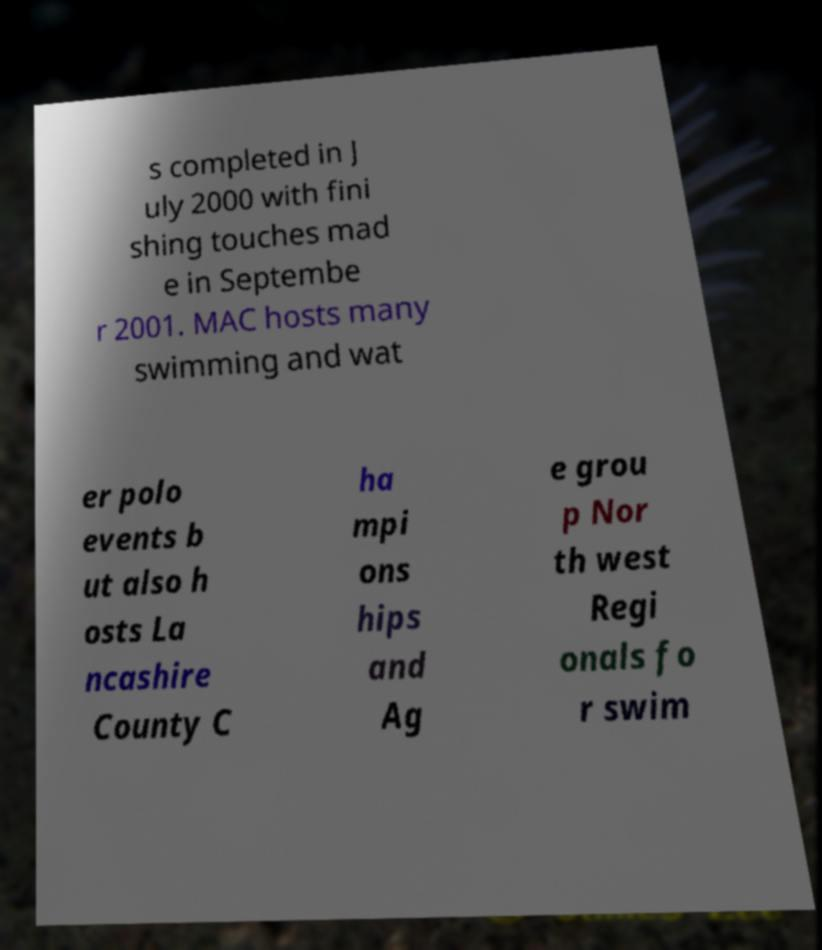Could you extract and type out the text from this image? s completed in J uly 2000 with fini shing touches mad e in Septembe r 2001. MAC hosts many swimming and wat er polo events b ut also h osts La ncashire County C ha mpi ons hips and Ag e grou p Nor th west Regi onals fo r swim 